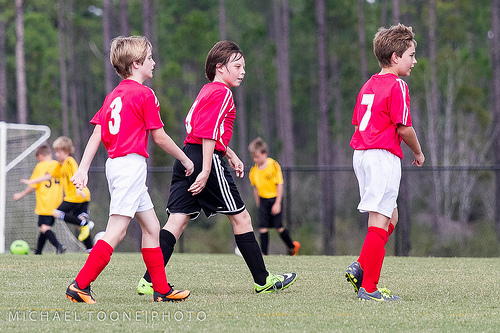<image>
Can you confirm if the ball is behind the boy? Yes. From this viewpoint, the ball is positioned behind the boy, with the boy partially or fully occluding the ball. 